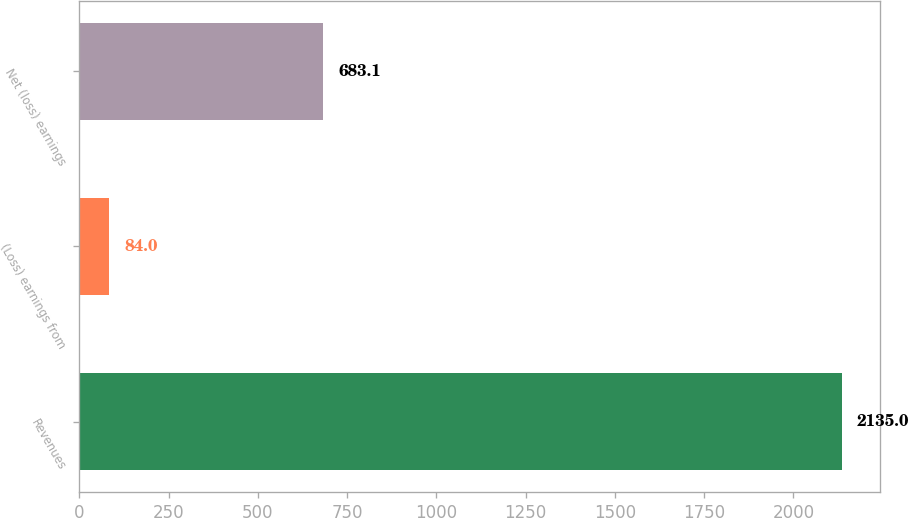Convert chart to OTSL. <chart><loc_0><loc_0><loc_500><loc_500><bar_chart><fcel>Revenues<fcel>(Loss) earnings from<fcel>Net (loss) earnings<nl><fcel>2135<fcel>84<fcel>683.1<nl></chart> 